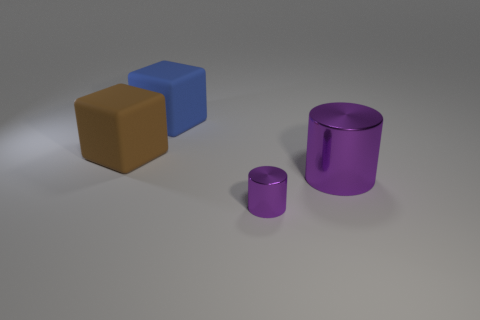Add 2 large rubber cubes. How many objects exist? 6 Subtract all large matte objects. Subtract all small purple metallic cylinders. How many objects are left? 1 Add 1 shiny cylinders. How many shiny cylinders are left? 3 Add 3 tiny red spheres. How many tiny red spheres exist? 3 Subtract 0 green balls. How many objects are left? 4 